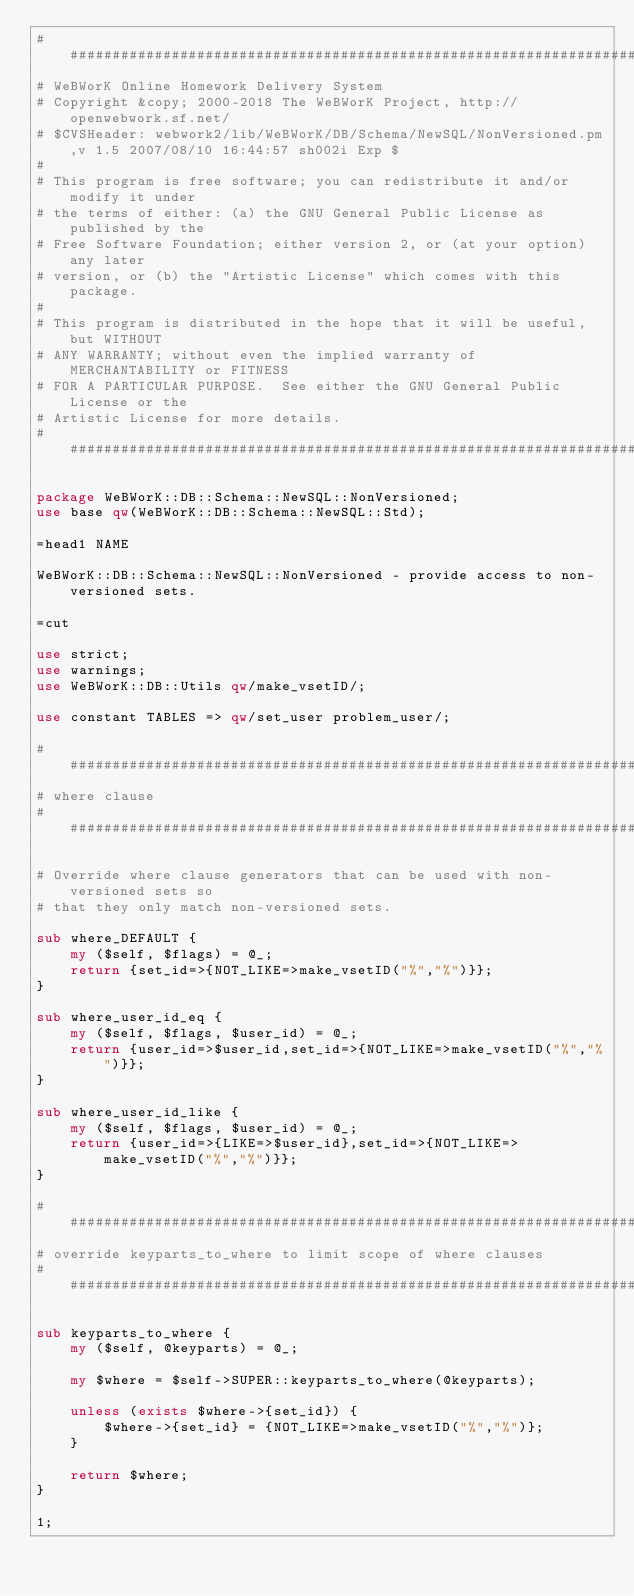<code> <loc_0><loc_0><loc_500><loc_500><_Perl_>################################################################################
# WeBWorK Online Homework Delivery System
# Copyright &copy; 2000-2018 The WeBWorK Project, http://openwebwork.sf.net/
# $CVSHeader: webwork2/lib/WeBWorK/DB/Schema/NewSQL/NonVersioned.pm,v 1.5 2007/08/10 16:44:57 sh002i Exp $
# 
# This program is free software; you can redistribute it and/or modify it under
# the terms of either: (a) the GNU General Public License as published by the
# Free Software Foundation; either version 2, or (at your option) any later
# version, or (b) the "Artistic License" which comes with this package.
# 
# This program is distributed in the hope that it will be useful, but WITHOUT
# ANY WARRANTY; without even the implied warranty of MERCHANTABILITY or FITNESS
# FOR A PARTICULAR PURPOSE.  See either the GNU General Public License or the
# Artistic License for more details.
################################################################################

package WeBWorK::DB::Schema::NewSQL::NonVersioned;
use base qw(WeBWorK::DB::Schema::NewSQL::Std);

=head1 NAME

WeBWorK::DB::Schema::NewSQL::NonVersioned - provide access to non-versioned sets.

=cut

use strict;
use warnings;
use WeBWorK::DB::Utils qw/make_vsetID/;

use constant TABLES => qw/set_user problem_user/;

################################################################################
# where clause
################################################################################

# Override where clause generators that can be used with non-versioned sets so
# that they only match non-versioned sets.

sub where_DEFAULT {
	my ($self, $flags) = @_;
	return {set_id=>{NOT_LIKE=>make_vsetID("%","%")}};
}

sub where_user_id_eq {
	my ($self, $flags, $user_id) = @_;
	return {user_id=>$user_id,set_id=>{NOT_LIKE=>make_vsetID("%","%")}};
}

sub where_user_id_like {
	my ($self, $flags, $user_id) = @_;
	return {user_id=>{LIKE=>$user_id},set_id=>{NOT_LIKE=>make_vsetID("%","%")}};
}

################################################################################
# override keyparts_to_where to limit scope of where clauses
################################################################################

sub keyparts_to_where {
	my ($self, @keyparts) = @_;
	
	my $where = $self->SUPER::keyparts_to_where(@keyparts);
	
	unless (exists $where->{set_id}) {
		$where->{set_id} = {NOT_LIKE=>make_vsetID("%","%")};
	}
	
	return $where;
}

1;
</code> 